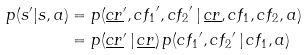<formula> <loc_0><loc_0><loc_500><loc_500>p ( s ^ { \prime } | s , a ) & = p ( { \underline { c r } } ^ { \prime } , { c f _ { 1 } } ^ { \prime } , { c f _ { 2 } } ^ { \prime } \, | \, \underline { c r } , c f _ { 1 } , { c f _ { 2 } } , a ) \\ & = p ( { \underline { c r } } ^ { \prime } \, | \, { \underline { c r } } ) \, p ( { c f _ { 1 } } ^ { \prime } , { c f _ { 2 } } ^ { \prime } \, | \, c f _ { 1 } , a ) \\</formula> 